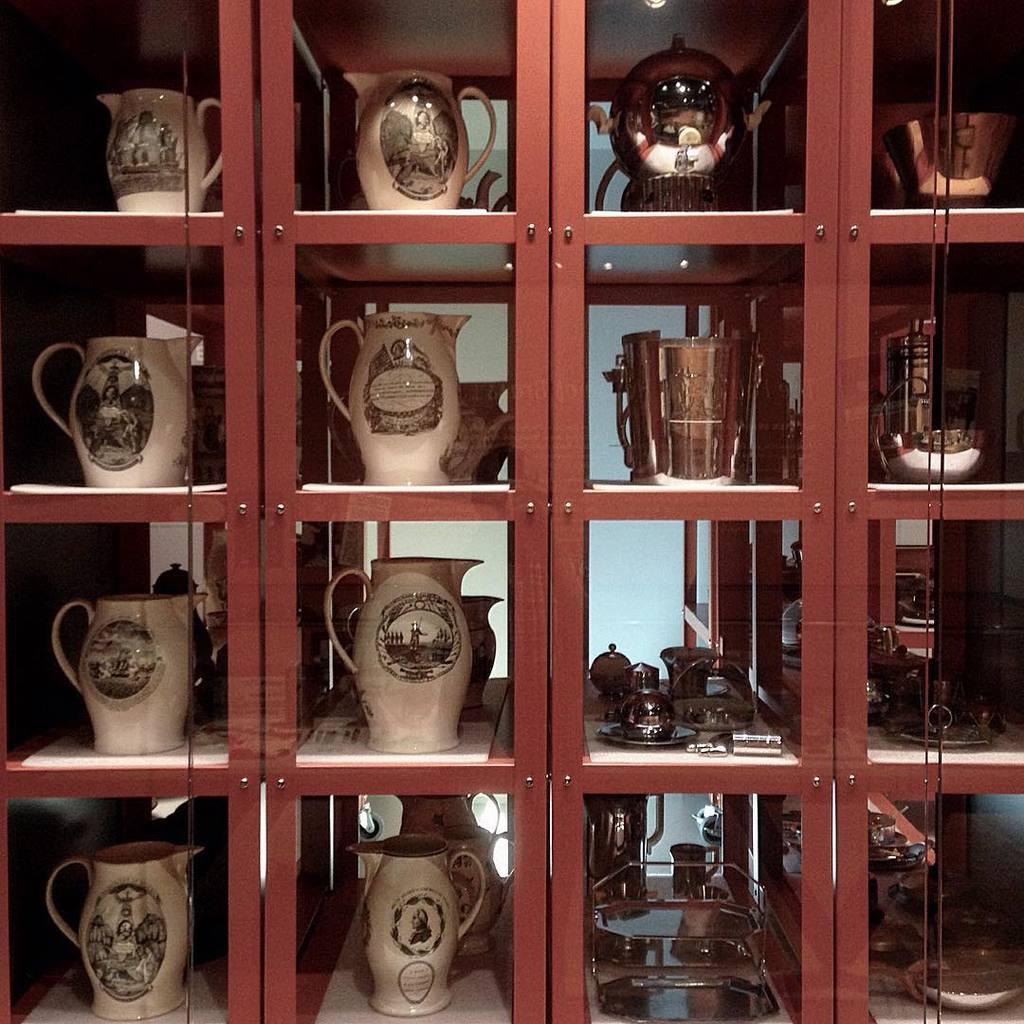Please provide a concise description of this image. In this image, we can see a cupboard contains some jugs. 